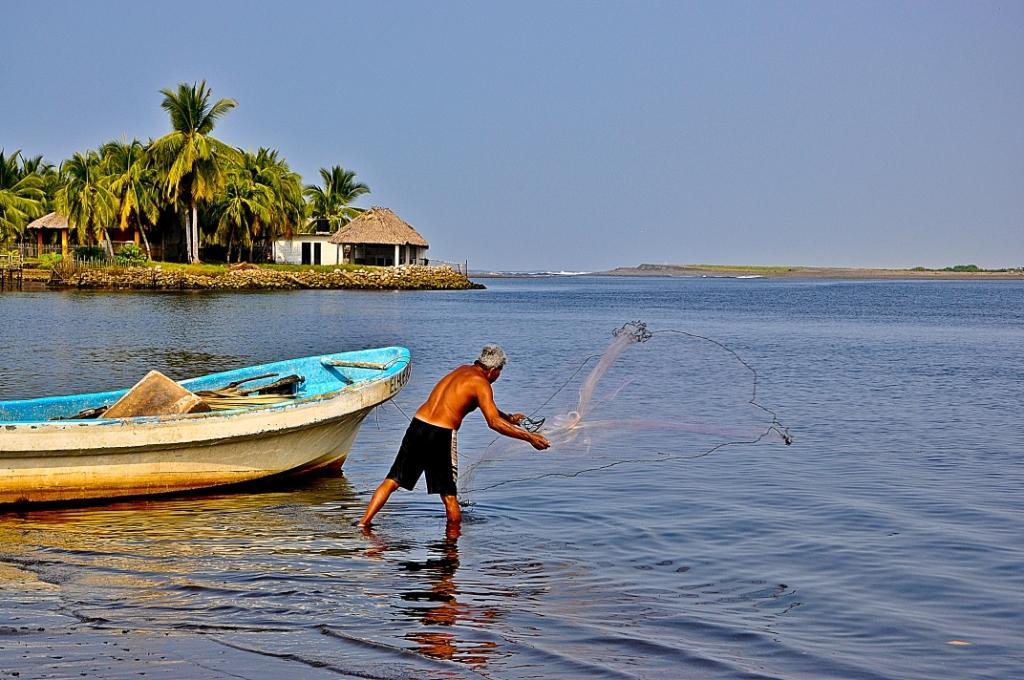Please provide a concise description of this image. In this image I can see the person to the side of the boat. The person is wearing the black color boxer and holding the net. The person is on the water. In the back I can see the house, trees and the blue sky. 